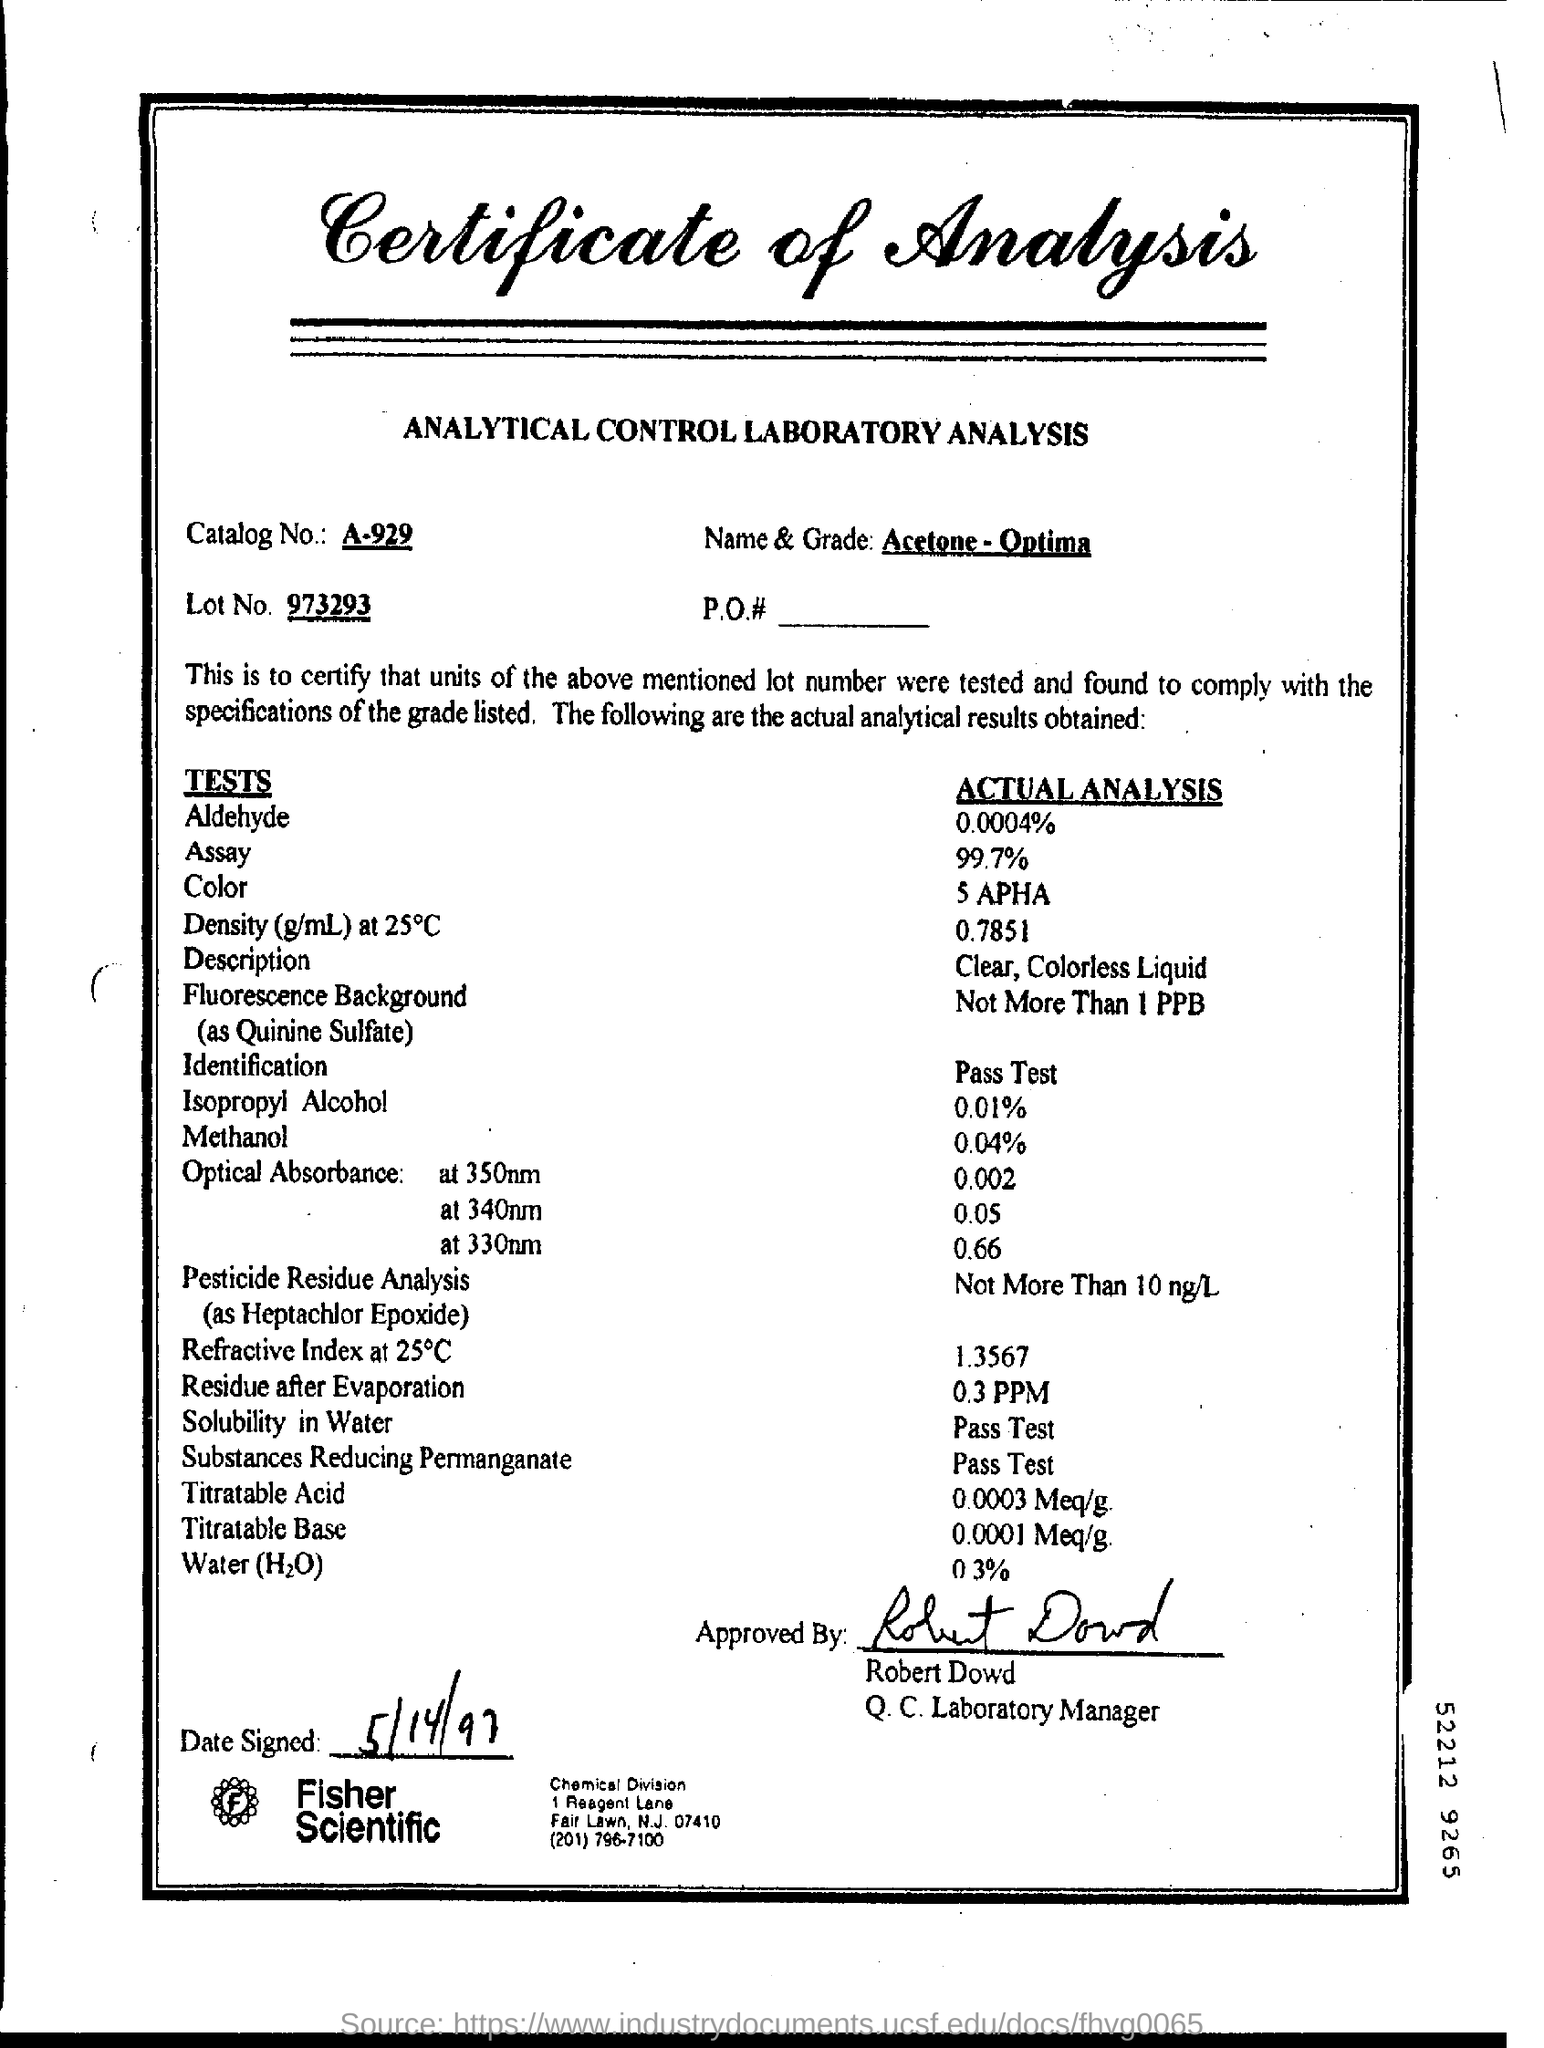What is the Catalog No.?
Provide a short and direct response. A-929. What is the Lot No.?
Give a very brief answer. 973293. What is the Name & Grade?
Make the answer very short. Acetone - optima. What is the Actual Analysis for Aldehyde?
Ensure brevity in your answer.  0.0004%. What is the Actual Analysis for Assay?
Provide a succinct answer. 99.7%. What is the Actual Analysis for Color?
Ensure brevity in your answer.  5 APHA. What is the Actual Analysis for Description?
Offer a very short reply. Clear, colorless liquid. When is the Date Signed?
Your response must be concise. 5/14/97. What is the Actual Analysis for Methanol?
Give a very brief answer. 0.04%. Who is it Approved By?
Ensure brevity in your answer.  Robert dowd. 